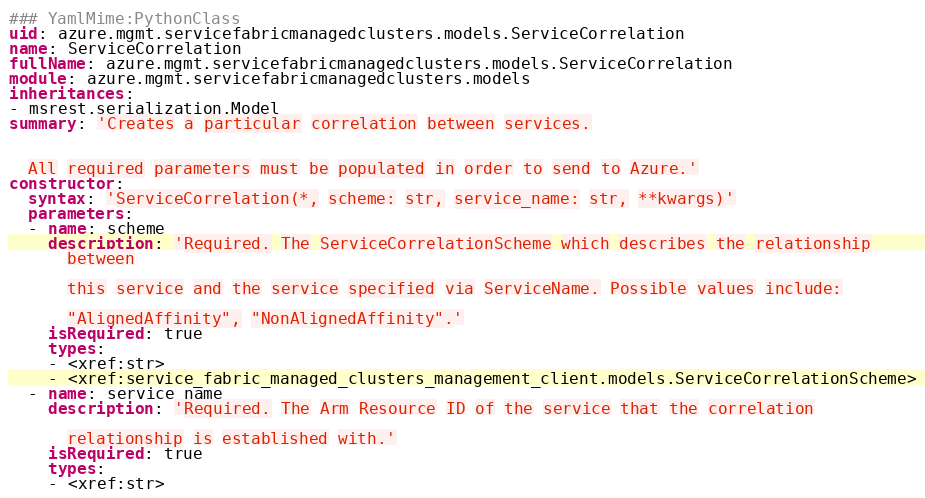Convert code to text. <code><loc_0><loc_0><loc_500><loc_500><_YAML_>### YamlMime:PythonClass
uid: azure.mgmt.servicefabricmanagedclusters.models.ServiceCorrelation
name: ServiceCorrelation
fullName: azure.mgmt.servicefabricmanagedclusters.models.ServiceCorrelation
module: azure.mgmt.servicefabricmanagedclusters.models
inheritances:
- msrest.serialization.Model
summary: 'Creates a particular correlation between services.


  All required parameters must be populated in order to send to Azure.'
constructor:
  syntax: 'ServiceCorrelation(*, scheme: str, service_name: str, **kwargs)'
  parameters:
  - name: scheme
    description: 'Required. The ServiceCorrelationScheme which describes the relationship
      between

      this service and the service specified via ServiceName. Possible values include:

      "AlignedAffinity", "NonAlignedAffinity".'
    isRequired: true
    types:
    - <xref:str>
    - <xref:service_fabric_managed_clusters_management_client.models.ServiceCorrelationScheme>
  - name: service_name
    description: 'Required. The Arm Resource ID of the service that the correlation

      relationship is established with.'
    isRequired: true
    types:
    - <xref:str>
</code> 